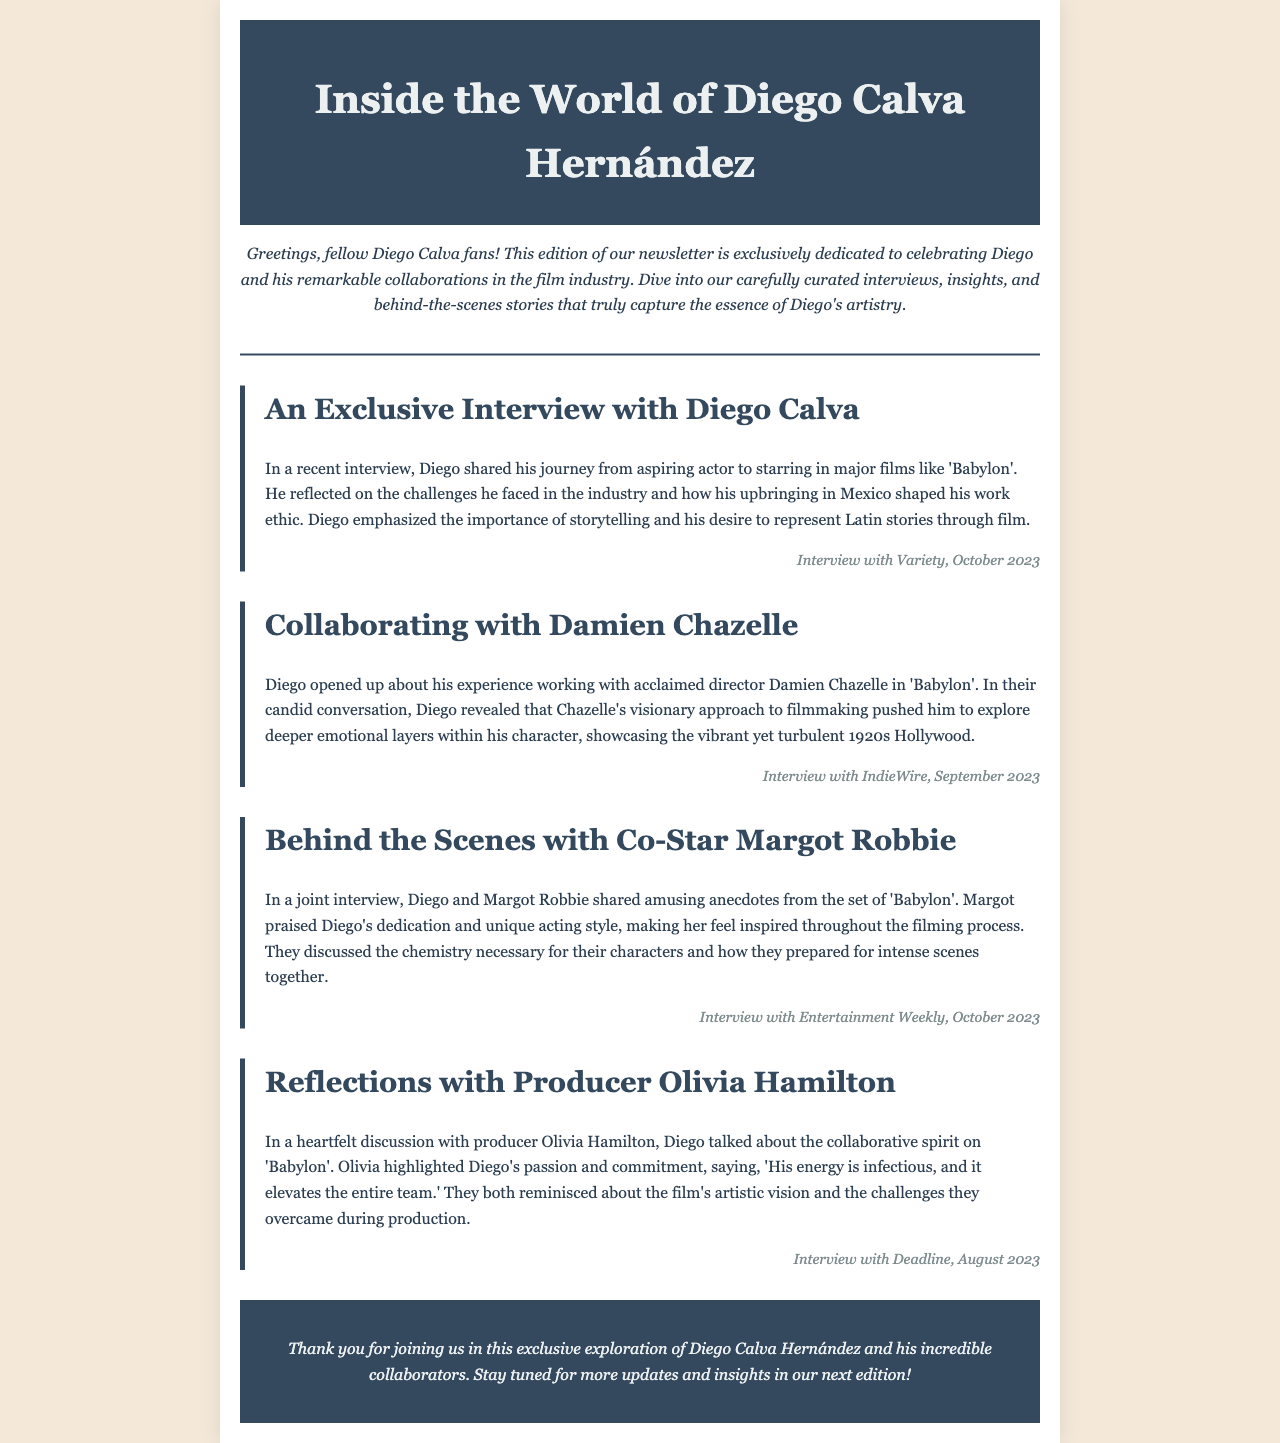what is the title of the newsletter? The title of the newsletter is prominently displayed at the top, indicating its focus on Diego Calva Hernández.
Answer: Inside the World of Diego Calva Hernández who is the director Diego Calva worked with in 'Babylon'? The document mentions Diego's collaboration with a renowned director during the production of 'Babylon'.
Answer: Damien Chazelle which actress did Diego share amusing anecdotes with? The newsletter discusses a joint interview where Diego shares stories from the set with an actress.
Answer: Margot Robbie what color is the background of the newsletter? The background color of the newsletter is specified in the styling of the document.
Answer: #f4e9d9 what is Diego's desire regarding storytelling? The newsletter highlights Diego's aspirations in storytelling within the film industry.
Answer: Represent Latin stories who praised Diego's dedication during filming? It is noted in the document that a co-star specifically acknowledged Diego's commitment to his craft during interviews.
Answer: Margot Robbie what type of document is this? The structure and content of the message are designed to convey information in a specific format, typical in media.
Answer: Newsletter when was the interview with Variety published? The time frame of the interview with Variety is mentioned in the document.
Answer: October 2023 what did Olivia Hamilton say about Diego's energy? The document features a quote from Olivia that highlights Diego's impact on the production team.
Answer: Infectious who discussed the collaborative spirit on 'Babylon'? The conversation about collaboration in the film highlights a specific person's contribution to the discussion.
Answer: Olivia Hamilton 